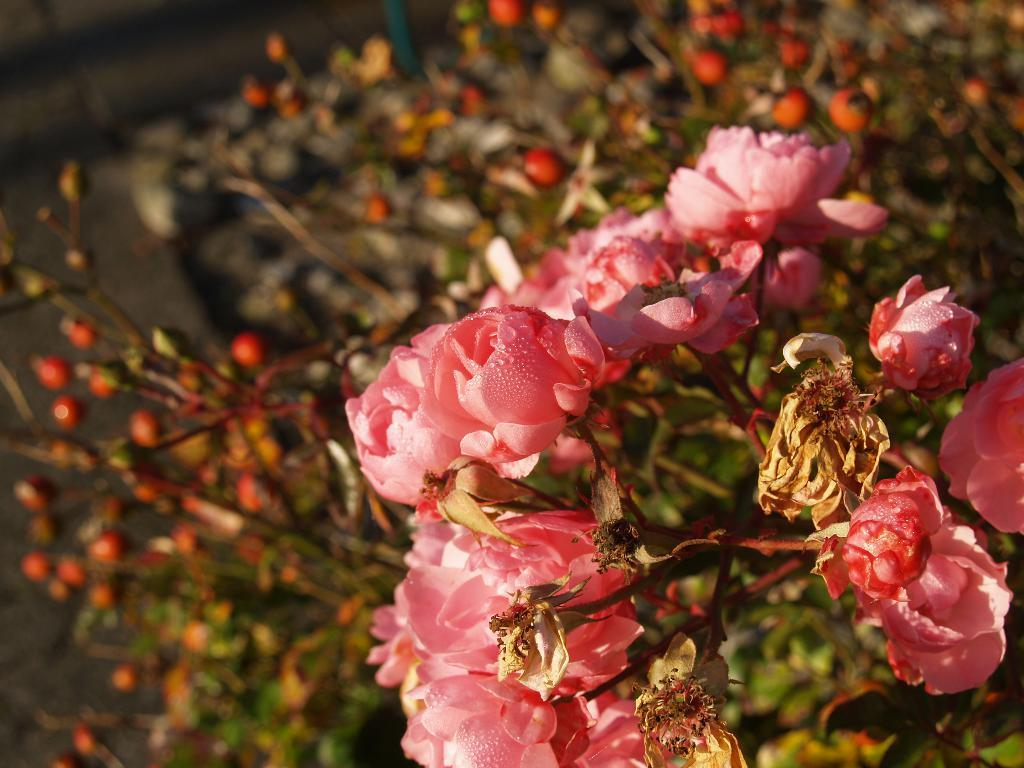What type of flora can be seen in the image? There are flowers in the image. What color are the flowers? The flowers are pink in color. What else can be seen in the background of the image besides the flowers? There are leaves in the background of the image. What type of bird can be seen sitting on the button in the image? There is no bird or button present in the image; it only features flowers and leaves. What type of apparel is the flower wearing in the image? Flowers do not wear apparel, as they are plants and not human-like beings. 